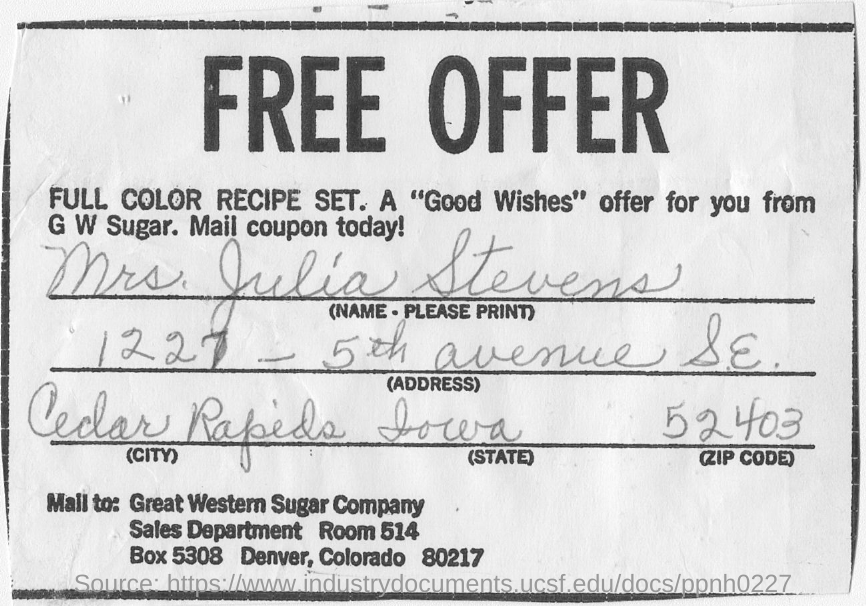Draw attention to some important aspects in this diagram. The company named in this coupon is Great Western Sugar Company. The coupon bears the name "Mrs. Julia Stevens. The headline is a free offer. 